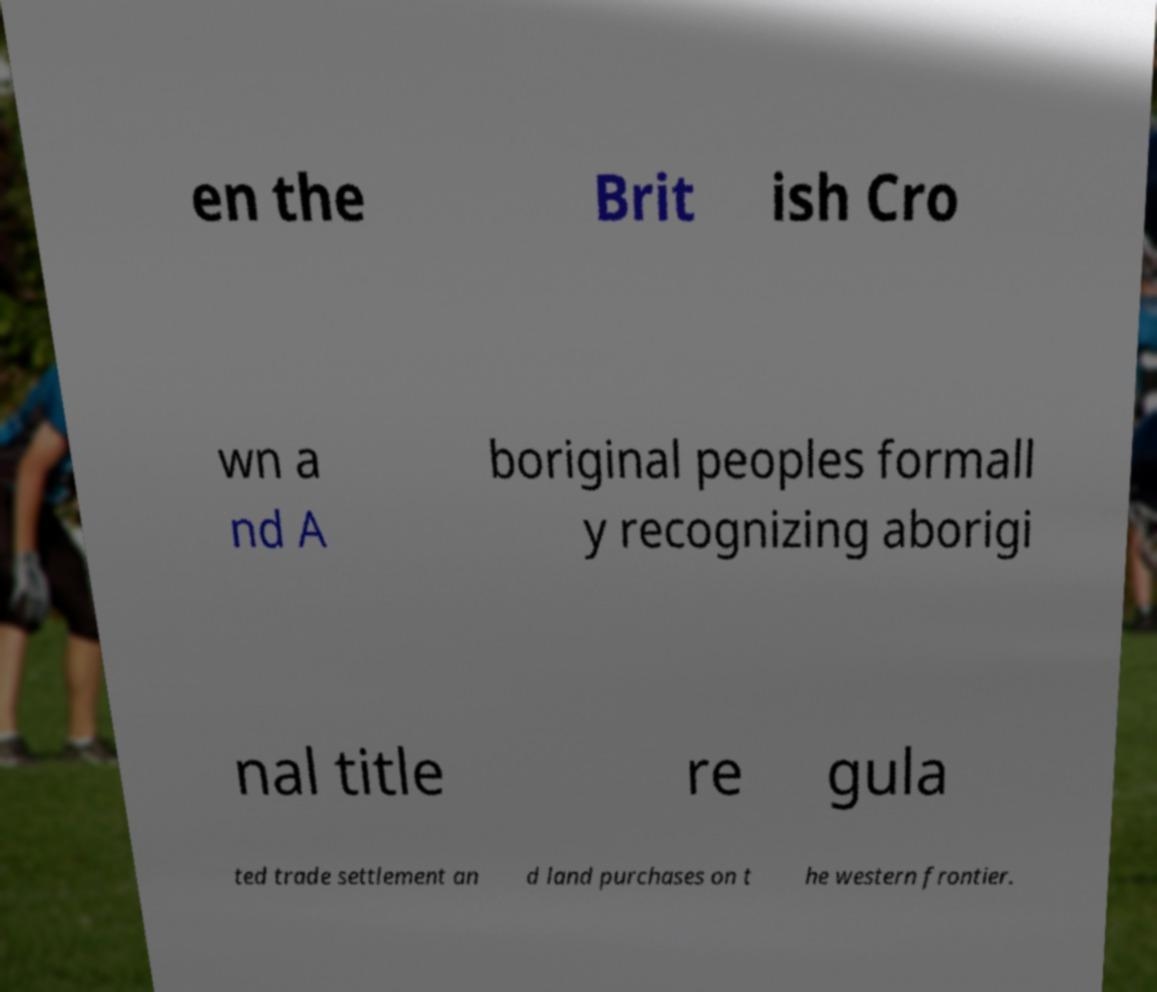Can you accurately transcribe the text from the provided image for me? en the Brit ish Cro wn a nd A boriginal peoples formall y recognizing aborigi nal title re gula ted trade settlement an d land purchases on t he western frontier. 